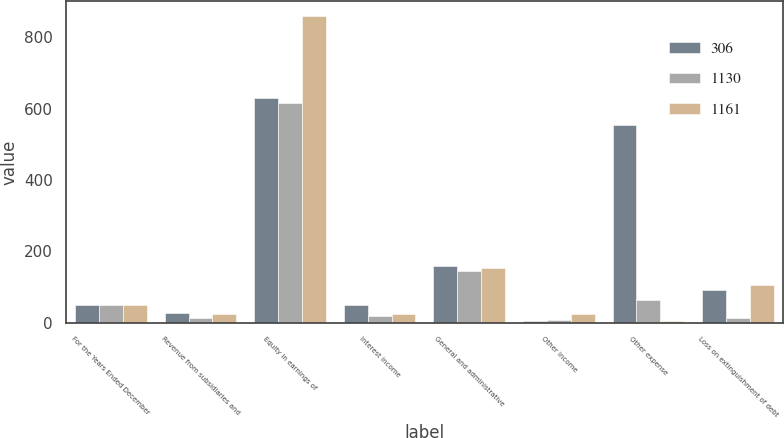Convert chart to OTSL. <chart><loc_0><loc_0><loc_500><loc_500><stacked_bar_chart><ecel><fcel>For the Years Ended December<fcel>Revenue from subsidiaries and<fcel>Equity in earnings of<fcel>Interest income<fcel>General and administrative<fcel>Other income<fcel>Other expense<fcel>Loss on extinguishment of debt<nl><fcel>306<fcel>49<fcel>28<fcel>630<fcel>49<fcel>158<fcel>5<fcel>554<fcel>92<nl><fcel>1130<fcel>49<fcel>14<fcel>615<fcel>19<fcel>144<fcel>7<fcel>65<fcel>14<nl><fcel>1161<fcel>49<fcel>24<fcel>859<fcel>24<fcel>154<fcel>24<fcel>6<fcel>105<nl></chart> 